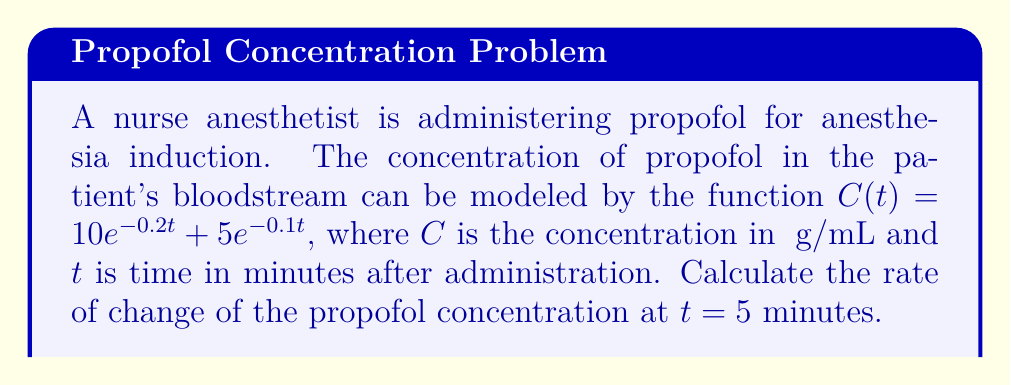Can you answer this question? To solve this problem, we need to find the derivative of the concentration function $C(t)$ and evaluate it at $t = 5$ minutes. This will give us the instantaneous rate of change at that time.

1) First, let's find the derivative of $C(t)$:

   $C(t) = 10e^{-0.2t} + 5e^{-0.1t}$
   
   Using the chain rule, we get:
   
   $$\frac{dC}{dt} = 10(-0.2)e^{-0.2t} + 5(-0.1)e^{-0.1t}$$
   $$\frac{dC}{dt} = -2e^{-0.2t} - 0.5e^{-0.1t}$$

2) Now, we need to evaluate this derivative at $t = 5$:

   $$\frac{dC}{dt}\bigg|_{t=5} = -2e^{-0.2(5)} - 0.5e^{-0.1(5)}$$

3) Let's calculate each term:

   $e^{-0.2(5)} = e^{-1} \approx 0.3679$
   $e^{-0.1(5)} = e^{-0.5} \approx 0.6065$

4) Substituting these values:

   $$\frac{dC}{dt}\bigg|_{t=5} = -2(0.3679) - 0.5(0.6065)$$
   $$= -0.7358 - 0.3033$$
   $$= -1.0391$$

Therefore, the rate of change of propofol concentration at t = 5 minutes is approximately -1.0391 μg/mL/min.
Answer: $-1.0391$ μg/mL/min 